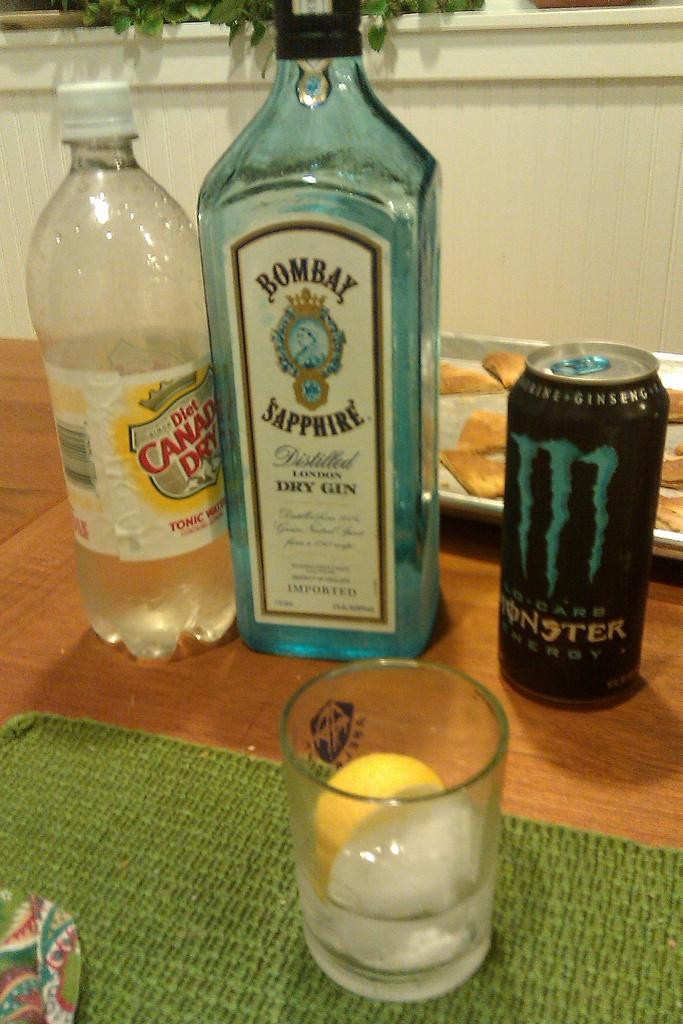<image>
Give a short and clear explanation of the subsequent image. A drink sits beside a bottle of tonic water, dry gin, and monster energy drink. 